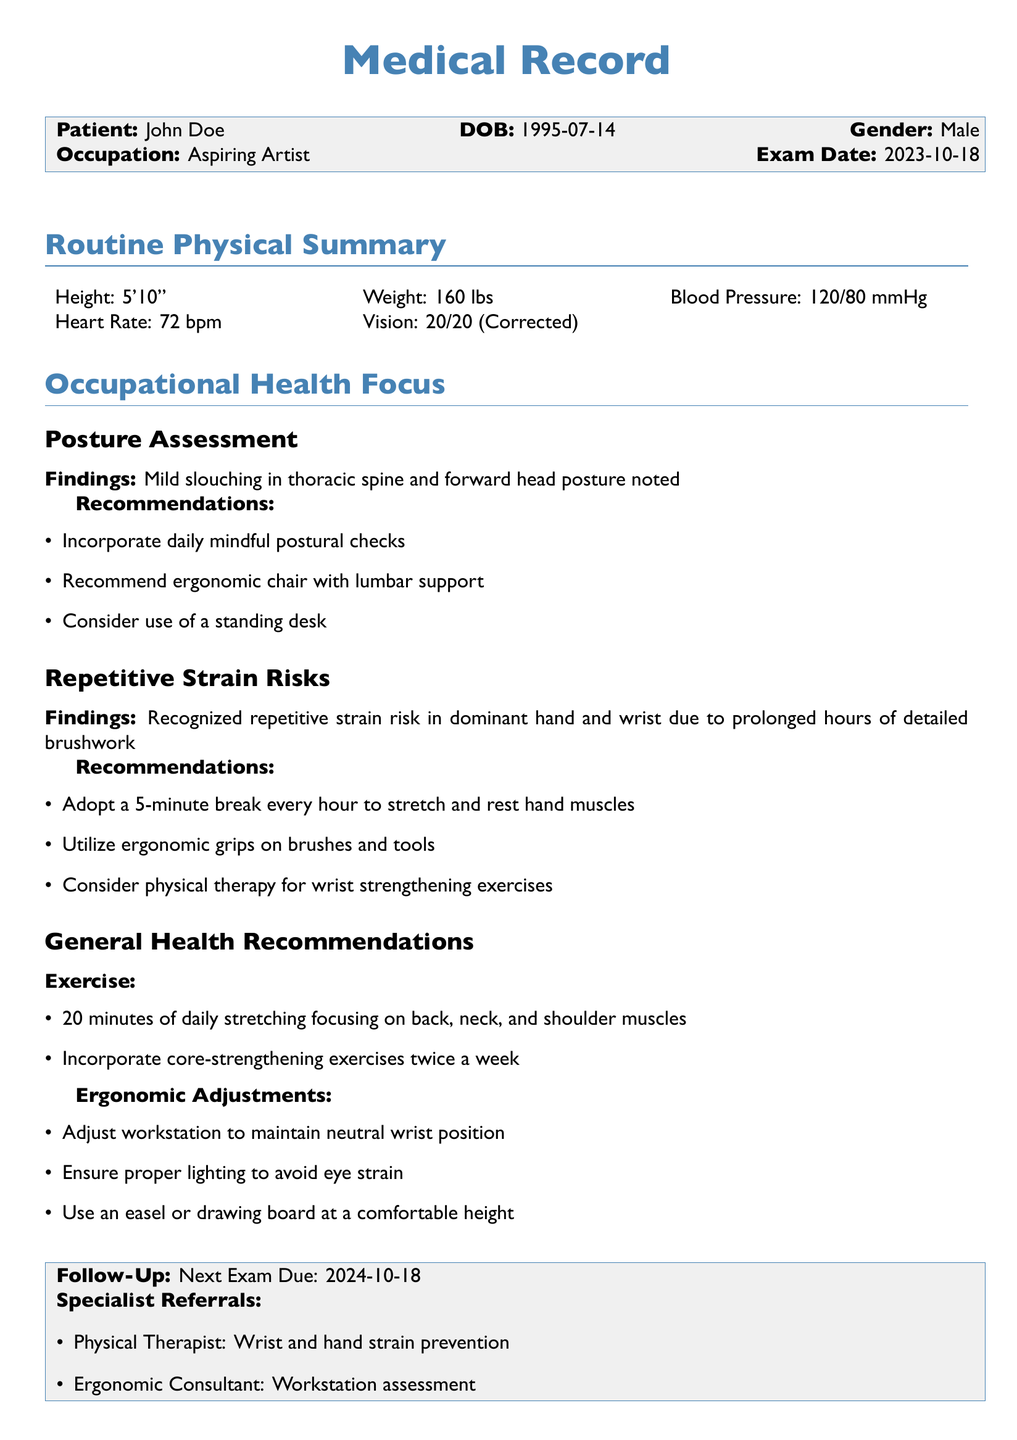what is the patient's name? The patient's name is stated in the document as John Doe.
Answer: John Doe what is the patient's occupation? The occupation of the patient is indicated in the document as an aspiring artist.
Answer: Aspiring Artist what are the blood pressure readings? The blood pressure readings are mentioned in the document as 120/80 mmHg.
Answer: 120/80 mmHg what posture issue was noted during the assessment? The document notes mild slouching in the thoracic spine and forward head posture.
Answer: Mild slouching what is one recommendation for improving posture? The document suggests incorporating daily mindful postural checks as one recommendation.
Answer: Daily mindful postural checks how often should the patient take breaks during work? The document states that the patient should adopt a 5-minute break every hour.
Answer: 5-minute break every hour what type of specialist is referred for wrist and hand strain prevention? The document specifies a physical therapist for wrist and hand strain prevention.
Answer: Physical Therapist when is the next exam due? The document indicates the next exam due date as 2024-10-18.
Answer: 2024-10-18 what exercise is recommended to strengthen the core? The document recommends incorporating core-strengthening exercises twice a week.
Answer: Core-strengthening exercises twice a week 